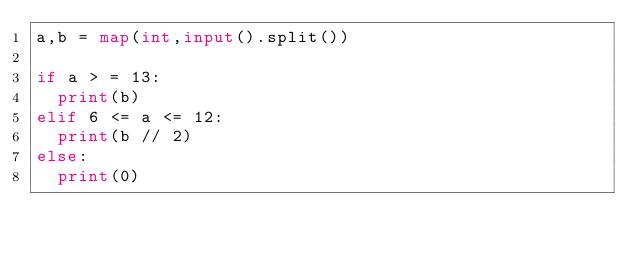Convert code to text. <code><loc_0><loc_0><loc_500><loc_500><_Python_>a,b = map(int,input().split())

if a > = 13:
  print(b)
elif 6 <= a <= 12:
  print(b // 2)
else:
  print(0)</code> 